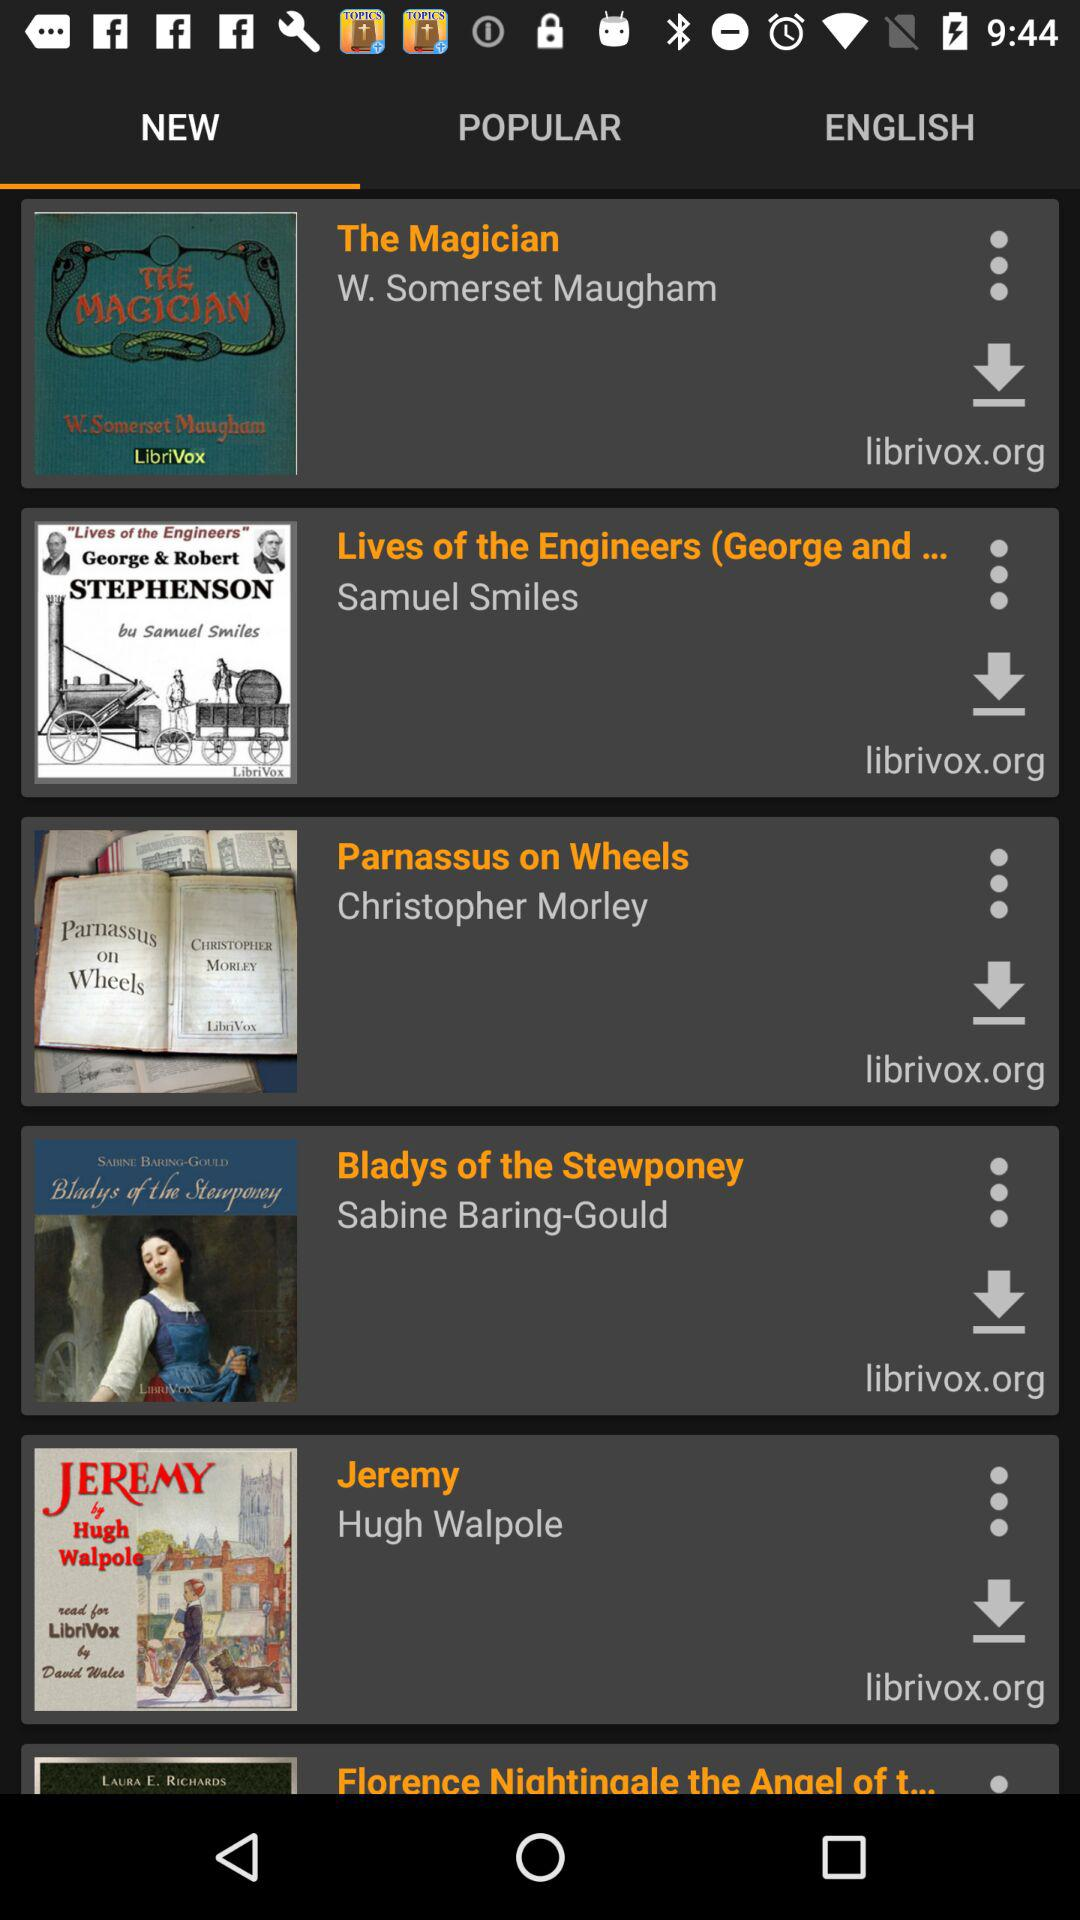Which books are listed in "POPULAR"?
When the provided information is insufficient, respond with <no answer>. <no answer> 